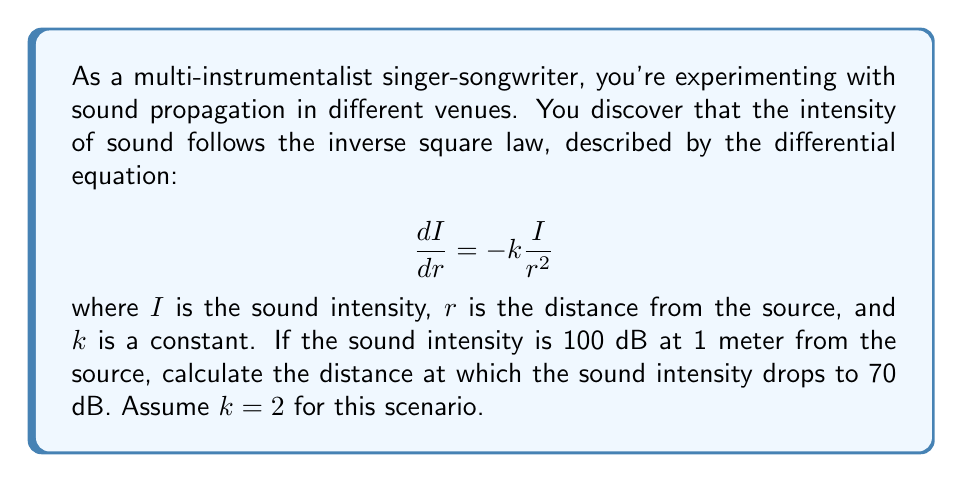Can you solve this math problem? Let's approach this problem step-by-step:

1) First, we need to solve the differential equation. It can be rewritten as:

   $$\frac{dI}{I} = -k\frac{dr}{r^2}$$

2) Integrating both sides:

   $$\int \frac{dI}{I} = -k\int \frac{dr}{r^2}$$

3) This gives us:

   $$\ln|I| = \frac{k}{r} + C$$

4) Taking the exponential of both sides:

   $$I = Ae^{\frac{k}{r}}$$

   where $A = e^C$ is a constant.

5) We're given that $I = 100$ when $r = 1$, so:

   $$100 = Ae^k$$
   $$A = 100e^{-k}$$

6) Our general solution is now:

   $$I = 100e^{-k}e^{\frac{k}{r}} = 100e^{k(\frac{1}{r}-1)}$$

7) We're looking for $r$ when $I = 70$, and we know $k = 2$:

   $$70 = 100e^{2(\frac{1}{r}-1)}$$

8) Dividing both sides by 100:

   $$0.7 = e^{2(\frac{1}{r}-1)}$$

9) Taking the natural log of both sides:

   $$\ln(0.7) = 2(\frac{1}{r}-1)$$

10) Solving for $r$:

    $$\frac{1}{r} = \frac{\ln(0.7)}{2} + 1$$
    $$r = \frac{2}{2 + \ln(0.7)} \approx 1.89$$
Answer: The sound intensity drops to 70 dB at approximately 1.89 meters from the source. 